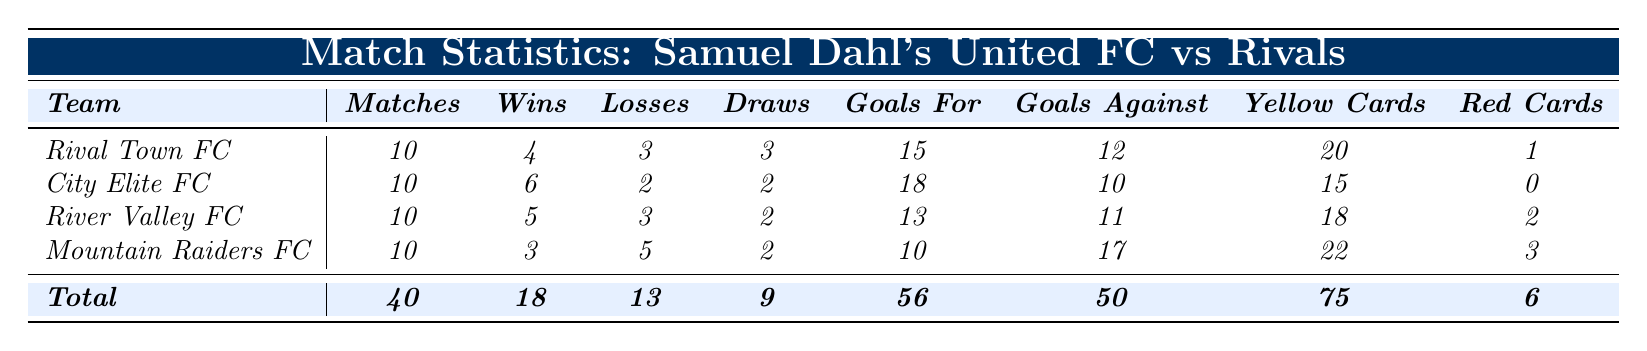What is the total number of matches played by Samuel Dahl's United FC's rivals? The table shows that all rival teams have played 10 matches each, and there are 4 rival teams. Therefore, the total matches played by the rivals is 10 matches multiplied by 4 teams, which equals 40 matches.
Answer: 40 How many wins did City Elite FC achieve? According to the table, City Elite FC has 6 wins listed under the “Wins” column.
Answer: 6 Which rival team has the highest number of goals scored? Looking at the “Goals For” column, City Elite FC scored 18 goals, which is more than any other rival team’s goals. No other team scores more than this value.
Answer: City Elite FC What is the win-loss ratio of River Valley FC? River Valley FC has 5 wins and 3 losses. The win-loss ratio is calculated by dividing wins by losses: 5/3, which equals approximately 1.67.
Answer: 1.67 How many goals did Samuel Dahl's United FC's rivals concede in total? To find the total goals conceded by all rivals, we sum the “Goals Against” column: 12 + 10 + 11 + 17 = 50.
Answer: 50 Did Mountain Raiders FC have more yellow cards than Samuel Dahl's United FC in total? Mountain Raiders FC has 22 yellow cards, while the total yellow cards for United FC is 75. Since 22 is less than 75, the answer is no.
Answer: No What is the average number of goals scored by the rival teams? To find the average, we sum the goals scored by the rivals: 15 + 18 + 13 + 10 = 56, then divide by the number of teams (4): 56/4 = 14.
Answer: 14 Which rival team had the fewest draws? Checking the “Draws” column, Mountain Raiders FC had 2 draws, while the others had 3 or more. Hence, Mountain Raiders FC had the fewest draws.
Answer: Mountain Raiders FC What is the total number of red cards given out to all rival teams combined? The total red cards are calculated by summing up all the red cards: 1 + 0 + 2 + 3 = 6.
Answer: 6 How many total losses does Samuel Dahl's United FC's rivals have? Summing the “Losses” column gives 3 (Rival Town FC) + 2 (City Elite FC) + 3 (River Valley FC) + 5 (Mountain Raiders FC) = 13 total losses.
Answer: 13 